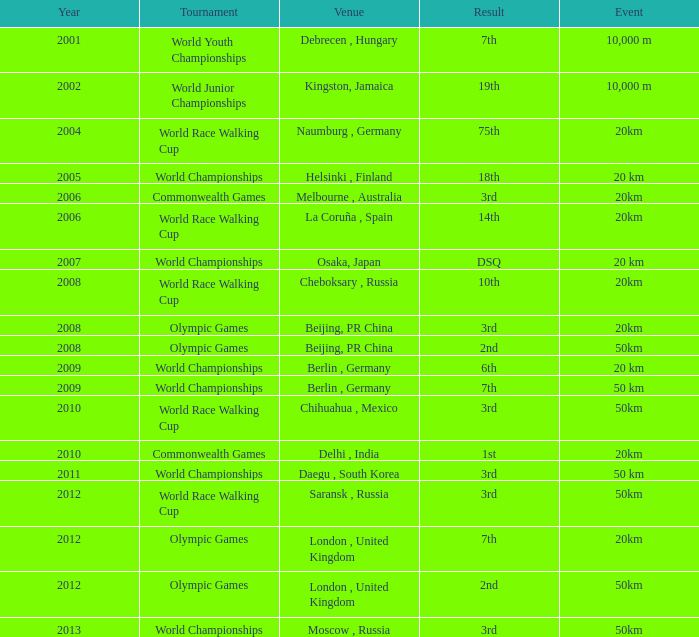What is the outcome of the world race walking cup competition held prior to 2010? 3rd. 